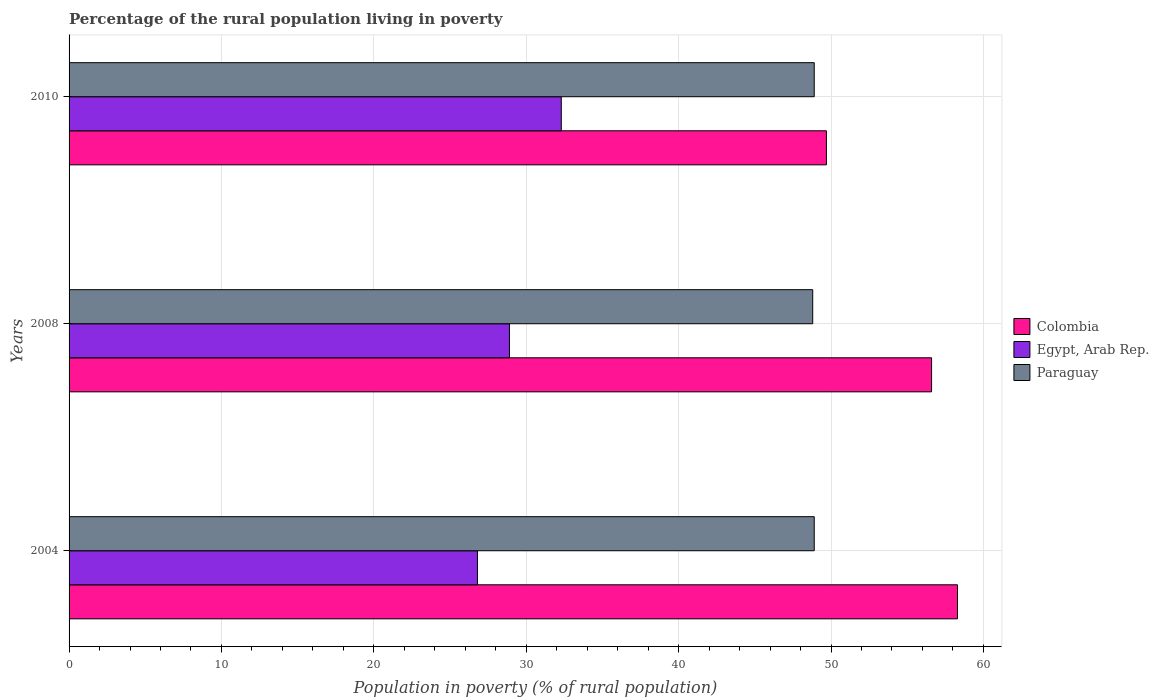How many different coloured bars are there?
Offer a terse response. 3. Are the number of bars per tick equal to the number of legend labels?
Give a very brief answer. Yes. How many bars are there on the 3rd tick from the top?
Your response must be concise. 3. In how many cases, is the number of bars for a given year not equal to the number of legend labels?
Provide a succinct answer. 0. What is the percentage of the rural population living in poverty in Paraguay in 2008?
Your answer should be very brief. 48.8. Across all years, what is the maximum percentage of the rural population living in poverty in Egypt, Arab Rep.?
Provide a short and direct response. 32.3. Across all years, what is the minimum percentage of the rural population living in poverty in Egypt, Arab Rep.?
Give a very brief answer. 26.8. In which year was the percentage of the rural population living in poverty in Paraguay maximum?
Make the answer very short. 2004. What is the difference between the percentage of the rural population living in poverty in Egypt, Arab Rep. in 2004 and that in 2008?
Make the answer very short. -2.1. What is the difference between the percentage of the rural population living in poverty in Colombia in 2004 and the percentage of the rural population living in poverty in Egypt, Arab Rep. in 2008?
Your answer should be compact. 29.4. What is the average percentage of the rural population living in poverty in Colombia per year?
Give a very brief answer. 54.87. In the year 2004, what is the difference between the percentage of the rural population living in poverty in Colombia and percentage of the rural population living in poverty in Paraguay?
Your answer should be very brief. 9.4. In how many years, is the percentage of the rural population living in poverty in Egypt, Arab Rep. greater than 48 %?
Offer a terse response. 0. What is the ratio of the percentage of the rural population living in poverty in Paraguay in 2004 to that in 2008?
Make the answer very short. 1. What is the difference between the highest and the lowest percentage of the rural population living in poverty in Paraguay?
Your answer should be very brief. 0.1. Is the sum of the percentage of the rural population living in poverty in Paraguay in 2004 and 2010 greater than the maximum percentage of the rural population living in poverty in Colombia across all years?
Your response must be concise. Yes. What does the 1st bar from the top in 2004 represents?
Keep it short and to the point. Paraguay. What does the 2nd bar from the bottom in 2008 represents?
Ensure brevity in your answer.  Egypt, Arab Rep. Is it the case that in every year, the sum of the percentage of the rural population living in poverty in Egypt, Arab Rep. and percentage of the rural population living in poverty in Paraguay is greater than the percentage of the rural population living in poverty in Colombia?
Your response must be concise. Yes. Are all the bars in the graph horizontal?
Provide a succinct answer. Yes. What is the difference between two consecutive major ticks on the X-axis?
Keep it short and to the point. 10. Are the values on the major ticks of X-axis written in scientific E-notation?
Offer a terse response. No. Does the graph contain grids?
Make the answer very short. Yes. Where does the legend appear in the graph?
Keep it short and to the point. Center right. How many legend labels are there?
Keep it short and to the point. 3. What is the title of the graph?
Make the answer very short. Percentage of the rural population living in poverty. What is the label or title of the X-axis?
Offer a very short reply. Population in poverty (% of rural population). What is the Population in poverty (% of rural population) in Colombia in 2004?
Ensure brevity in your answer.  58.3. What is the Population in poverty (% of rural population) of Egypt, Arab Rep. in 2004?
Provide a short and direct response. 26.8. What is the Population in poverty (% of rural population) of Paraguay in 2004?
Offer a very short reply. 48.9. What is the Population in poverty (% of rural population) of Colombia in 2008?
Offer a terse response. 56.6. What is the Population in poverty (% of rural population) in Egypt, Arab Rep. in 2008?
Ensure brevity in your answer.  28.9. What is the Population in poverty (% of rural population) of Paraguay in 2008?
Offer a terse response. 48.8. What is the Population in poverty (% of rural population) in Colombia in 2010?
Provide a short and direct response. 49.7. What is the Population in poverty (% of rural population) of Egypt, Arab Rep. in 2010?
Your answer should be compact. 32.3. What is the Population in poverty (% of rural population) in Paraguay in 2010?
Offer a very short reply. 48.9. Across all years, what is the maximum Population in poverty (% of rural population) of Colombia?
Give a very brief answer. 58.3. Across all years, what is the maximum Population in poverty (% of rural population) of Egypt, Arab Rep.?
Provide a short and direct response. 32.3. Across all years, what is the maximum Population in poverty (% of rural population) in Paraguay?
Give a very brief answer. 48.9. Across all years, what is the minimum Population in poverty (% of rural population) in Colombia?
Provide a succinct answer. 49.7. Across all years, what is the minimum Population in poverty (% of rural population) in Egypt, Arab Rep.?
Provide a succinct answer. 26.8. Across all years, what is the minimum Population in poverty (% of rural population) in Paraguay?
Provide a short and direct response. 48.8. What is the total Population in poverty (% of rural population) of Colombia in the graph?
Keep it short and to the point. 164.6. What is the total Population in poverty (% of rural population) of Egypt, Arab Rep. in the graph?
Keep it short and to the point. 88. What is the total Population in poverty (% of rural population) of Paraguay in the graph?
Your response must be concise. 146.6. What is the difference between the Population in poverty (% of rural population) of Colombia in 2004 and that in 2008?
Your answer should be very brief. 1.7. What is the difference between the Population in poverty (% of rural population) in Egypt, Arab Rep. in 2004 and that in 2010?
Give a very brief answer. -5.5. What is the difference between the Population in poverty (% of rural population) in Colombia in 2008 and that in 2010?
Make the answer very short. 6.9. What is the difference between the Population in poverty (% of rural population) in Egypt, Arab Rep. in 2008 and that in 2010?
Your response must be concise. -3.4. What is the difference between the Population in poverty (% of rural population) in Paraguay in 2008 and that in 2010?
Ensure brevity in your answer.  -0.1. What is the difference between the Population in poverty (% of rural population) in Colombia in 2004 and the Population in poverty (% of rural population) in Egypt, Arab Rep. in 2008?
Provide a short and direct response. 29.4. What is the difference between the Population in poverty (% of rural population) in Egypt, Arab Rep. in 2004 and the Population in poverty (% of rural population) in Paraguay in 2008?
Offer a very short reply. -22. What is the difference between the Population in poverty (% of rural population) of Egypt, Arab Rep. in 2004 and the Population in poverty (% of rural population) of Paraguay in 2010?
Your answer should be compact. -22.1. What is the difference between the Population in poverty (% of rural population) of Colombia in 2008 and the Population in poverty (% of rural population) of Egypt, Arab Rep. in 2010?
Your response must be concise. 24.3. What is the difference between the Population in poverty (% of rural population) of Colombia in 2008 and the Population in poverty (% of rural population) of Paraguay in 2010?
Your answer should be compact. 7.7. What is the average Population in poverty (% of rural population) of Colombia per year?
Provide a succinct answer. 54.87. What is the average Population in poverty (% of rural population) of Egypt, Arab Rep. per year?
Give a very brief answer. 29.33. What is the average Population in poverty (% of rural population) in Paraguay per year?
Give a very brief answer. 48.87. In the year 2004, what is the difference between the Population in poverty (% of rural population) of Colombia and Population in poverty (% of rural population) of Egypt, Arab Rep.?
Your response must be concise. 31.5. In the year 2004, what is the difference between the Population in poverty (% of rural population) of Colombia and Population in poverty (% of rural population) of Paraguay?
Your response must be concise. 9.4. In the year 2004, what is the difference between the Population in poverty (% of rural population) of Egypt, Arab Rep. and Population in poverty (% of rural population) of Paraguay?
Your answer should be compact. -22.1. In the year 2008, what is the difference between the Population in poverty (% of rural population) of Colombia and Population in poverty (% of rural population) of Egypt, Arab Rep.?
Your response must be concise. 27.7. In the year 2008, what is the difference between the Population in poverty (% of rural population) in Colombia and Population in poverty (% of rural population) in Paraguay?
Your answer should be very brief. 7.8. In the year 2008, what is the difference between the Population in poverty (% of rural population) of Egypt, Arab Rep. and Population in poverty (% of rural population) of Paraguay?
Your answer should be very brief. -19.9. In the year 2010, what is the difference between the Population in poverty (% of rural population) in Egypt, Arab Rep. and Population in poverty (% of rural population) in Paraguay?
Give a very brief answer. -16.6. What is the ratio of the Population in poverty (% of rural population) in Egypt, Arab Rep. in 2004 to that in 2008?
Ensure brevity in your answer.  0.93. What is the ratio of the Population in poverty (% of rural population) of Paraguay in 2004 to that in 2008?
Provide a short and direct response. 1. What is the ratio of the Population in poverty (% of rural population) in Colombia in 2004 to that in 2010?
Provide a succinct answer. 1.17. What is the ratio of the Population in poverty (% of rural population) in Egypt, Arab Rep. in 2004 to that in 2010?
Offer a very short reply. 0.83. What is the ratio of the Population in poverty (% of rural population) of Paraguay in 2004 to that in 2010?
Provide a short and direct response. 1. What is the ratio of the Population in poverty (% of rural population) in Colombia in 2008 to that in 2010?
Offer a terse response. 1.14. What is the ratio of the Population in poverty (% of rural population) of Egypt, Arab Rep. in 2008 to that in 2010?
Ensure brevity in your answer.  0.89. What is the difference between the highest and the second highest Population in poverty (% of rural population) in Colombia?
Your response must be concise. 1.7. What is the difference between the highest and the second highest Population in poverty (% of rural population) of Paraguay?
Your answer should be compact. 0. What is the difference between the highest and the lowest Population in poverty (% of rural population) in Colombia?
Your response must be concise. 8.6. 